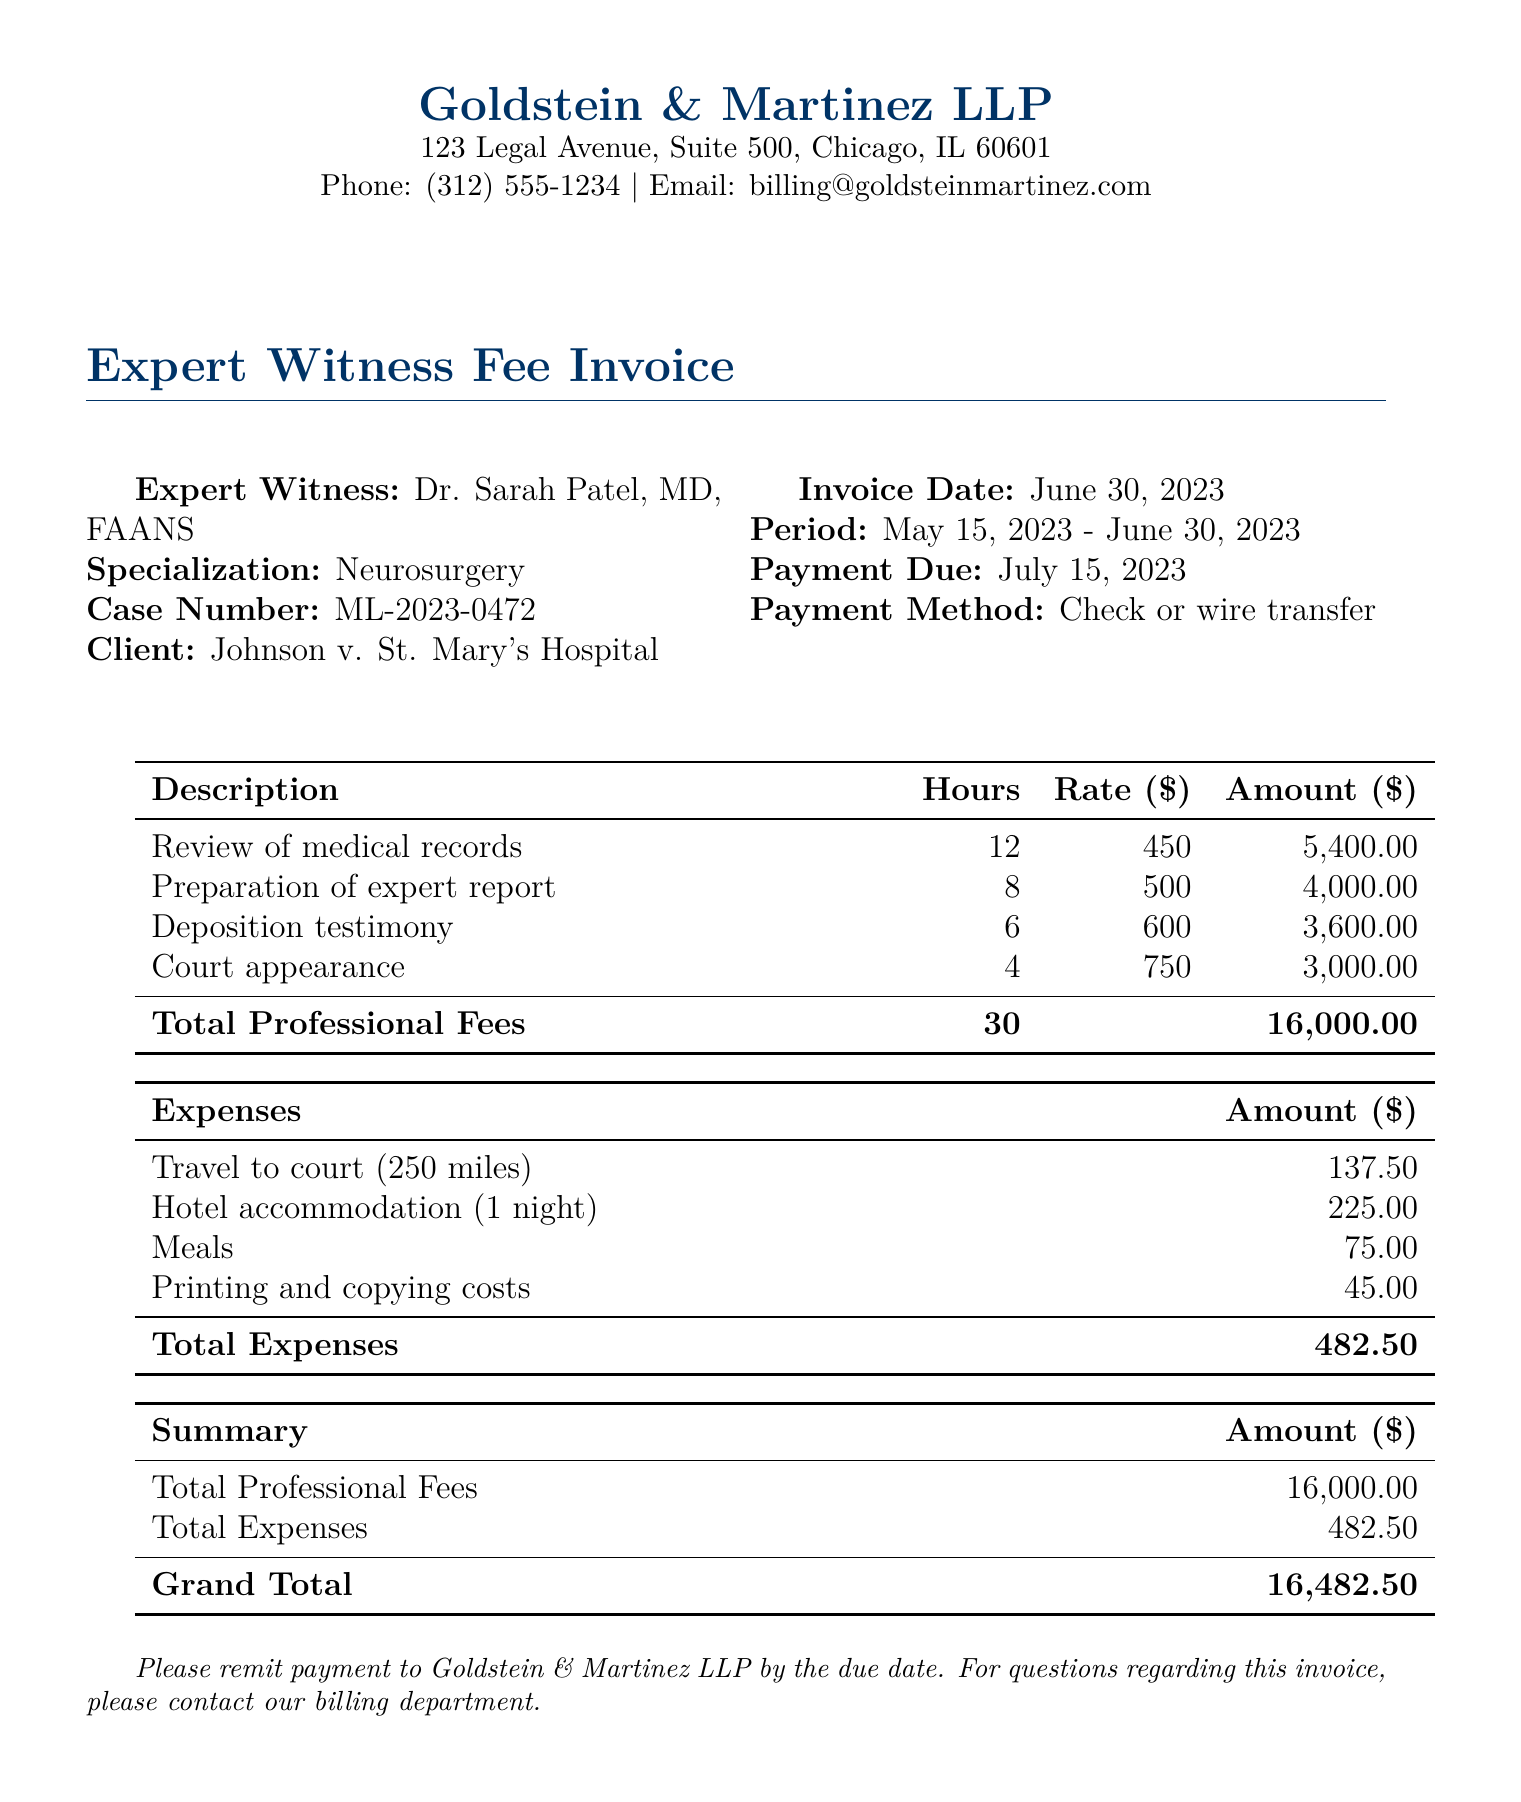What is the invoice date? The invoice date is clearly stated in the document.
Answer: June 30, 2023 Who is the expert witness? The name of the expert witness is listed at the beginning of the invoice.
Answer: Dr. Sarah Patel, MD, FAANS What is the total professional fees amount? The total professional fees are summarized in the document.
Answer: 16,000.00 How many hours were billed for preparation of the expert report? The hours billed for preparation of the expert report are provided in the table.
Answer: 8 What is the total amount for travel expenses? The travel expenses are broken down in the expense section of the invoice.
Answer: 137.50 What is the payment due date? The payment due date is specified in the invoice details.
Answer: July 15, 2023 What is the total amount due for the invoice? The grand total at the end of the summary indicates the total amount due.
Answer: 16,482.50 How many total hours are billed for all services? The total hours billed are listed in the professional fees table.
Answer: 30 What specialization does the expert witness have? The expert witness's specialization is mentioned alongside their details.
Answer: Neurosurgery 